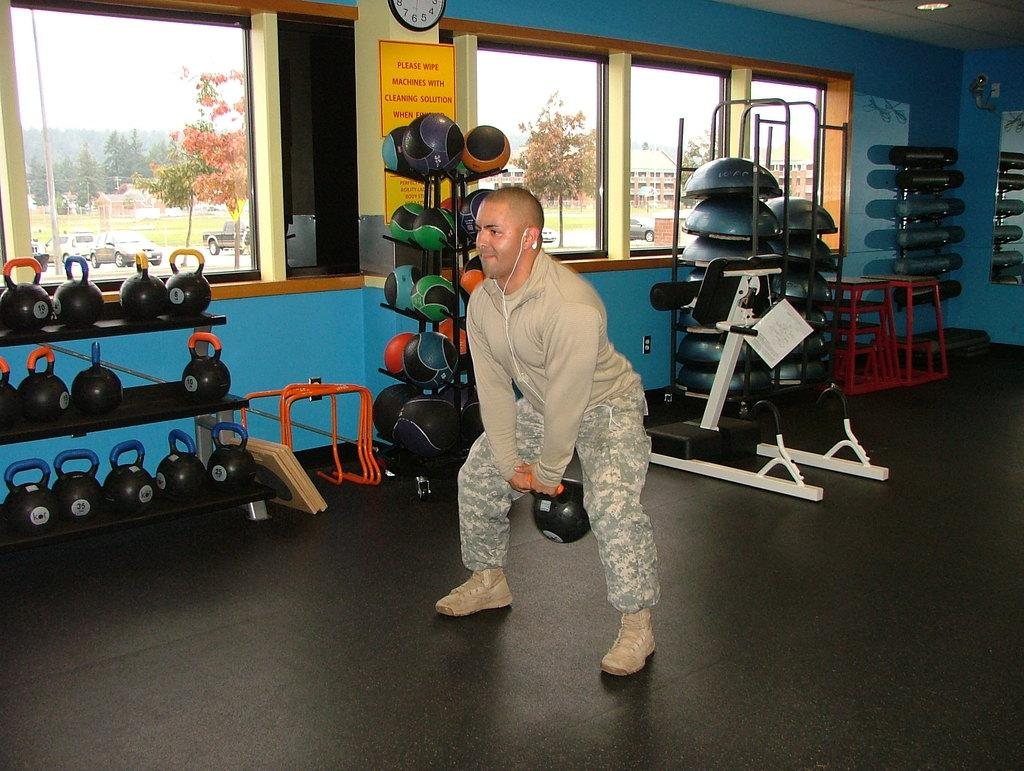<image>
Create a compact narrative representing the image presented. A man lifting a weight in a gym with a sign about wiping with cleaning solution behind him. 